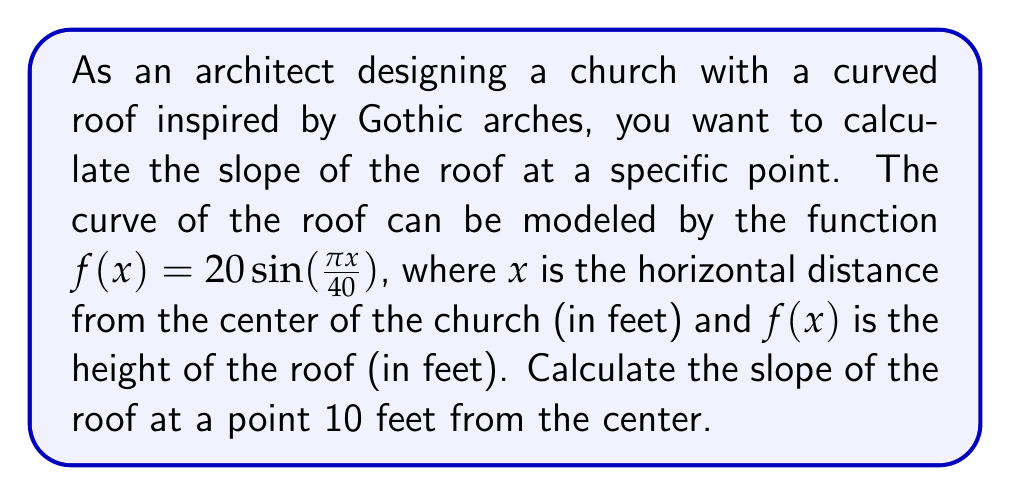Provide a solution to this math problem. To find the slope of the curved roof at a specific point, we need to calculate the derivative of the function $f(x)$ and evaluate it at the given point. Let's follow these steps:

1) The given function is $f(x) = 20 \sin(\frac{\pi x}{40})$

2) To find the derivative, we use the chain rule:
   $$f'(x) = 20 \cdot \cos(\frac{\pi x}{40}) \cdot \frac{d}{dx}(\frac{\pi x}{40})$$

3) Simplify:
   $$f'(x) = 20 \cdot \cos(\frac{\pi x}{40}) \cdot \frac{\pi}{40}$$
   $$f'(x) = \frac{\pi}{2} \cos(\frac{\pi x}{40})$$

4) We need to evaluate this at $x = 10$:
   $$f'(10) = \frac{\pi}{2} \cos(\frac{\pi \cdot 10}{40})$$
   $$f'(10) = \frac{\pi}{2} \cos(\frac{\pi}{4})$$

5) Recall that $\cos(\frac{\pi}{4}) = \frac{\sqrt{2}}{2}$

6) Therefore:
   $$f'(10) = \frac{\pi}{2} \cdot \frac{\sqrt{2}}{2} = \frac{\pi\sqrt{2}}{4}$$

This value represents the slope of the roof at a point 10 feet from the center of the church.
Answer: $\frac{\pi\sqrt{2}}{4}$ 